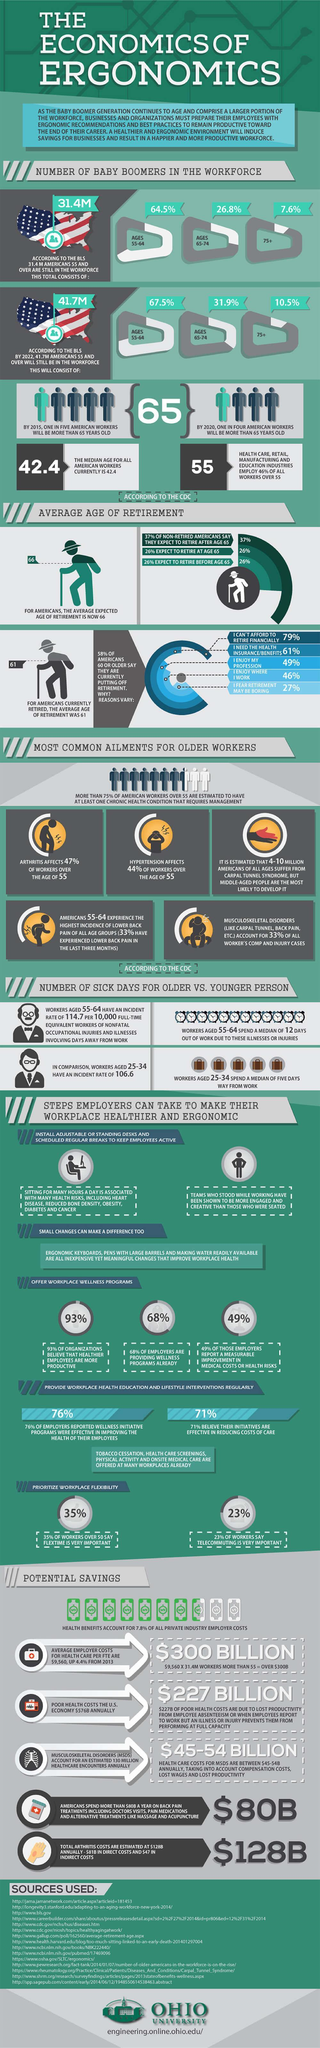What percentage of employers are providing health schemes to employees, 93%, 68%, or 49%?
Answer the question with a short phrase. 68% What percentage of Americans expect to retire at or before the age of 65? 26% What percentage of people below 75 years are still in the US workforce? 99.4% What percentage of people less than 65 years are still in the US workforce? 64.5% 